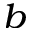Convert formula to latex. <formula><loc_0><loc_0><loc_500><loc_500>^ { b }</formula> 